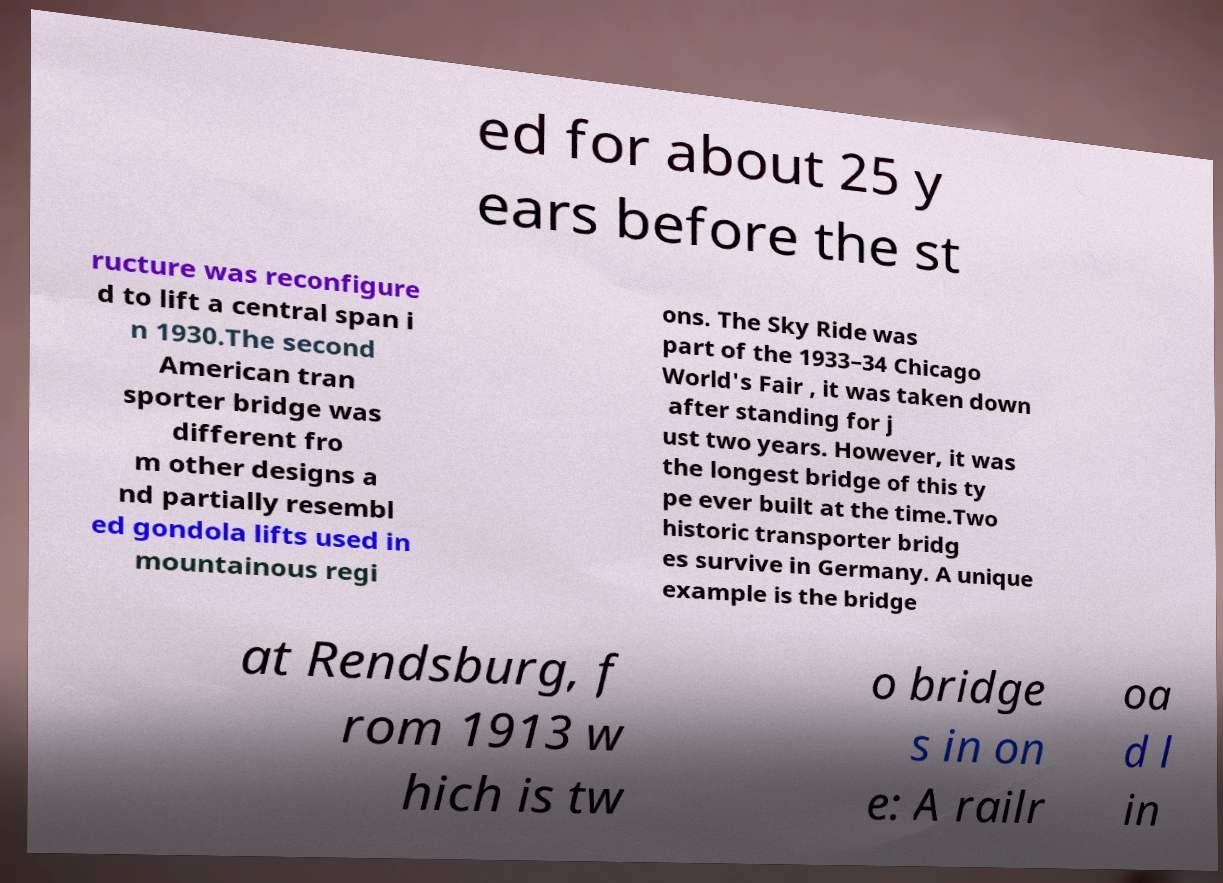Please read and relay the text visible in this image. What does it say? ed for about 25 y ears before the st ructure was reconfigure d to lift a central span i n 1930.The second American tran sporter bridge was different fro m other designs a nd partially resembl ed gondola lifts used in mountainous regi ons. The Sky Ride was part of the 1933–34 Chicago World's Fair , it was taken down after standing for j ust two years. However, it was the longest bridge of this ty pe ever built at the time.Two historic transporter bridg es survive in Germany. A unique example is the bridge at Rendsburg, f rom 1913 w hich is tw o bridge s in on e: A railr oa d l in 